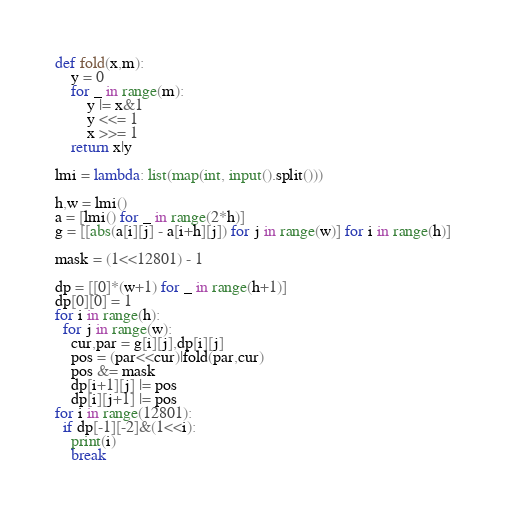Convert code to text. <code><loc_0><loc_0><loc_500><loc_500><_Python_>def fold(x,m):
    y = 0
    for _ in range(m):
        y |= x&1
        y <<= 1
        x >>= 1
    return x|y

lmi = lambda: list(map(int, input().split()))

h,w = lmi()
a = [lmi() for _ in range(2*h)]
g = [[abs(a[i][j] - a[i+h][j]) for j in range(w)] for i in range(h)]

mask = (1<<12801) - 1

dp = [[0]*(w+1) for _ in range(h+1)]
dp[0][0] = 1
for i in range(h):
  for j in range(w):
    cur,par = g[i][j],dp[i][j]
    pos = (par<<cur)|fold(par,cur)
    pos &= mask
    dp[i+1][j] |= pos
    dp[i][j+1] |= pos
for i in range(12801):
  if dp[-1][-2]&(1<<i):
    print(i)
    break
</code> 